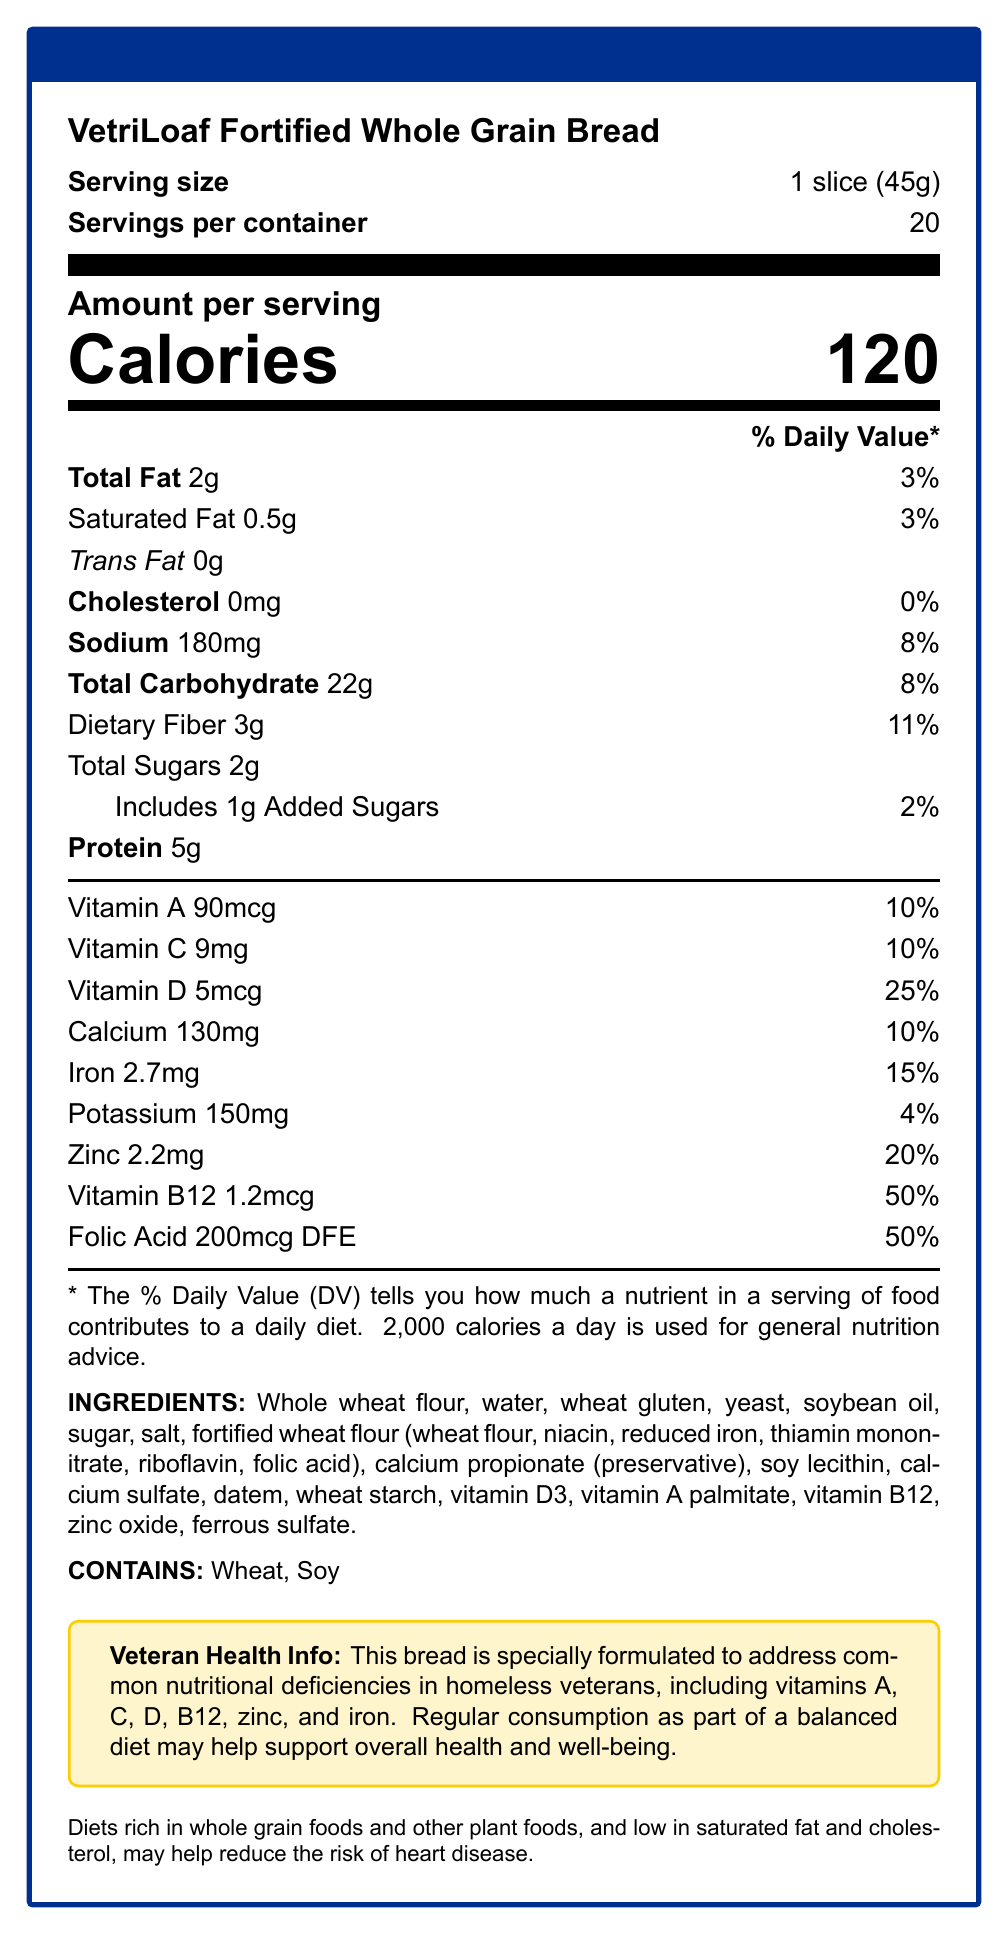what is the serving size for VetriLoaf Fortified Whole Grain Bread? The serving size is clearly stated at the beginning of the Nutrition Facts section as "1 slice (45g)."
Answer: 1 slice (45g) how many servings per container does VetriLoaf have? The Nutrition Facts label shows "Servings per container" as 20.
Answer: 20 how many calories are in one serving of VetriLoaf? The "Calories" section of the label shows there are 120 calories per serving.
Answer: 120 what percentage of the daily value of Vitamin D does each slice provide? The label indicates that each slice of VetriLoaf provides 25% of the daily value of Vitamin D.
Answer: 25% list all the vitamins and minerals specifically mentioned that VetriLoaf helps to address in homeless veterans. These vitamins and minerals are listed in the "Veteran Health Info" section as those that VetriLoaf helps to address.
Answer: Vitamins A, C, D, B12, zinc, iron does VetriLoaf contain any trans fat? The label shows "Trans Fat 0g," indicating that there is no trans fat in the bread.
Answer: No what are the ingredients in VetriLoaf that might cause allergies? The "CONTAINS" section of the label lists wheat and soy as potential allergens.
Answer: Wheat, Soy how much dietary fiber is in one serving of VetriLoaf? The "Dietary Fiber" part of the label shows that one serving contains 3g of dietary fiber.
Answer: 3g what is the health claim mentioned on the label? This health claim is mentioned at the end of the document.
Answer: Diets rich in whole grain foods and other plant foods, and low in saturated fat and cholesterol, may help reduce the risk of heart disease. how much added sugar is in each serving? The label shows "Includes 1g Added Sugars" under the total sugars section.
Answer: 1g how much iron is in one serving, as a percentage of daily value? The label indicates that each serving provides 15% of the daily value of iron.
Answer: 15% Multiple-choice:
which vitamin has the highest daily value percentage in VetriLoaf? 
A. Vitamin A 
B. Vitamin C 
C. Vitamin D 
D. Vitamin B12 Vitamin B12 has the highest daily value percentage at 50%.
Answer: D. Vitamin B12 Multiple-choice:
how much calcium is in one serving of VetriLoaf?
1. 100mg 
2. 130mg 
3. 150mg 
4. 180mg The label shows that one serving contains 130mg of calcium.
Answer: 2. 130mg is VetriLoaf designed for general consumption or for a specific group of people? The "Veteran Health Info" section states that the bread is formulated to address common nutritional deficiencies in homeless veterans.
Answer: Specifically designed for homeless veterans true or false: the bread is formulated to reduce the risk of diabetes. The health claim specifically mentions reducing the risk of heart disease, not diabetes.
Answer: False summarize the purpose and benefits of VetriLoaf Fortified Whole Grain Bread. The summary captures the key points from various sections of the document, including the specific nutritional needs addressed, the general health claims, and the intended consumer group.
Answer: The purpose of VetriLoaf is to provide a nutritious bread option for homeless veterans, addressing common nutritional deficiencies such as vitamins A, C, D, B12, zinc, and iron. Each serving contains essential nutrients, is low in saturated fat and cholesterol, and may help reduce the risk of heart disease. what is the manufacturing date of VetriLoaf? The document does not provide any details about the manufacturing date.
Answer: Not enough information 